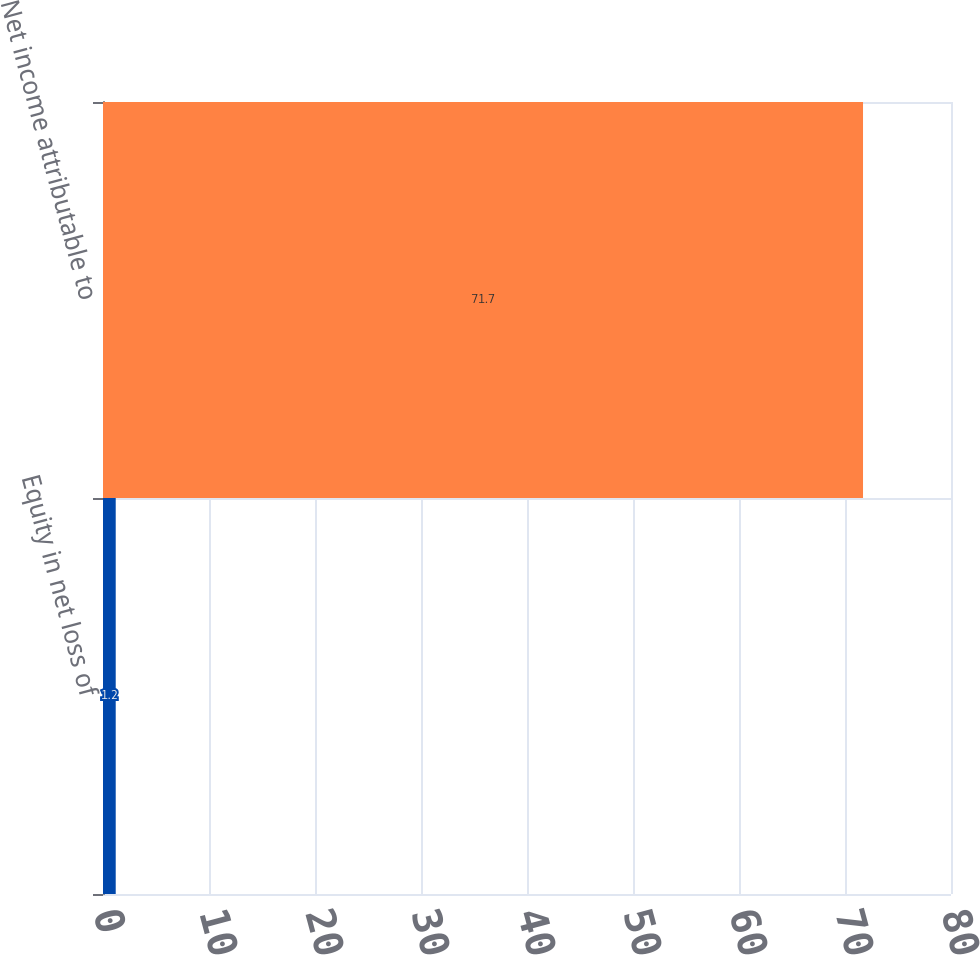Convert chart to OTSL. <chart><loc_0><loc_0><loc_500><loc_500><bar_chart><fcel>Equity in net loss of<fcel>Net income attributable to<nl><fcel>1.2<fcel>71.7<nl></chart> 